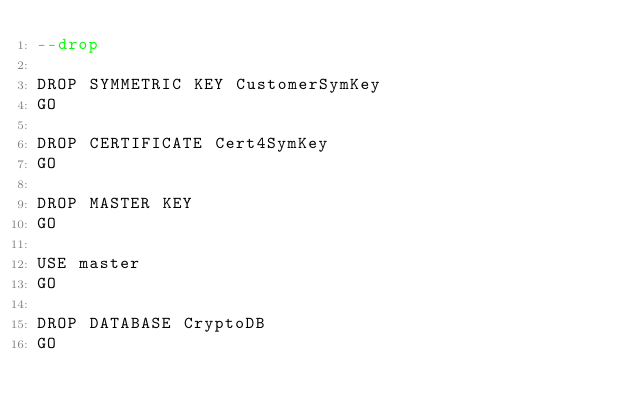Convert code to text. <code><loc_0><loc_0><loc_500><loc_500><_SQL_>--drop

DROP SYMMETRIC KEY CustomerSymKey
GO

DROP CERTIFICATE Cert4SymKey
GO

DROP MASTER KEY
GO

USE master
GO

DROP DATABASE CryptoDB
GO</code> 